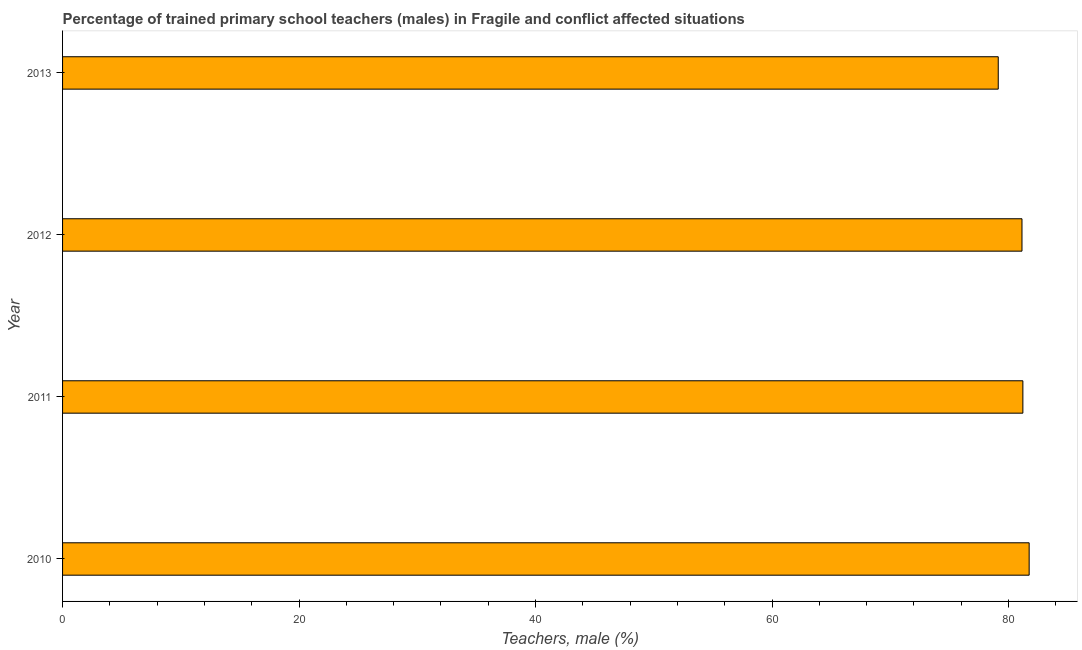Does the graph contain grids?
Your response must be concise. No. What is the title of the graph?
Give a very brief answer. Percentage of trained primary school teachers (males) in Fragile and conflict affected situations. What is the label or title of the X-axis?
Make the answer very short. Teachers, male (%). What is the label or title of the Y-axis?
Offer a very short reply. Year. What is the percentage of trained male teachers in 2013?
Ensure brevity in your answer.  79.13. Across all years, what is the maximum percentage of trained male teachers?
Offer a very short reply. 81.74. Across all years, what is the minimum percentage of trained male teachers?
Ensure brevity in your answer.  79.13. In which year was the percentage of trained male teachers minimum?
Your response must be concise. 2013. What is the sum of the percentage of trained male teachers?
Offer a terse response. 323.22. What is the difference between the percentage of trained male teachers in 2011 and 2012?
Provide a succinct answer. 0.07. What is the average percentage of trained male teachers per year?
Your answer should be very brief. 80.81. What is the median percentage of trained male teachers?
Provide a succinct answer. 81.17. Do a majority of the years between 2010 and 2012 (inclusive) have percentage of trained male teachers greater than 76 %?
Offer a terse response. Yes. What is the difference between the highest and the second highest percentage of trained male teachers?
Provide a short and direct response. 0.53. Is the sum of the percentage of trained male teachers in 2011 and 2012 greater than the maximum percentage of trained male teachers across all years?
Give a very brief answer. Yes. What is the difference between the highest and the lowest percentage of trained male teachers?
Your answer should be very brief. 2.61. Are all the bars in the graph horizontal?
Give a very brief answer. Yes. What is the difference between two consecutive major ticks on the X-axis?
Offer a terse response. 20. What is the Teachers, male (%) in 2010?
Your answer should be very brief. 81.74. What is the Teachers, male (%) in 2011?
Keep it short and to the point. 81.21. What is the Teachers, male (%) in 2012?
Ensure brevity in your answer.  81.14. What is the Teachers, male (%) of 2013?
Keep it short and to the point. 79.13. What is the difference between the Teachers, male (%) in 2010 and 2011?
Keep it short and to the point. 0.53. What is the difference between the Teachers, male (%) in 2010 and 2012?
Your response must be concise. 0.61. What is the difference between the Teachers, male (%) in 2010 and 2013?
Make the answer very short. 2.61. What is the difference between the Teachers, male (%) in 2011 and 2012?
Your response must be concise. 0.08. What is the difference between the Teachers, male (%) in 2011 and 2013?
Provide a succinct answer. 2.08. What is the difference between the Teachers, male (%) in 2012 and 2013?
Keep it short and to the point. 2.01. What is the ratio of the Teachers, male (%) in 2010 to that in 2011?
Offer a terse response. 1.01. What is the ratio of the Teachers, male (%) in 2010 to that in 2012?
Offer a terse response. 1.01. What is the ratio of the Teachers, male (%) in 2010 to that in 2013?
Provide a succinct answer. 1.03. What is the ratio of the Teachers, male (%) in 2011 to that in 2012?
Your answer should be compact. 1. What is the ratio of the Teachers, male (%) in 2012 to that in 2013?
Make the answer very short. 1.02. 